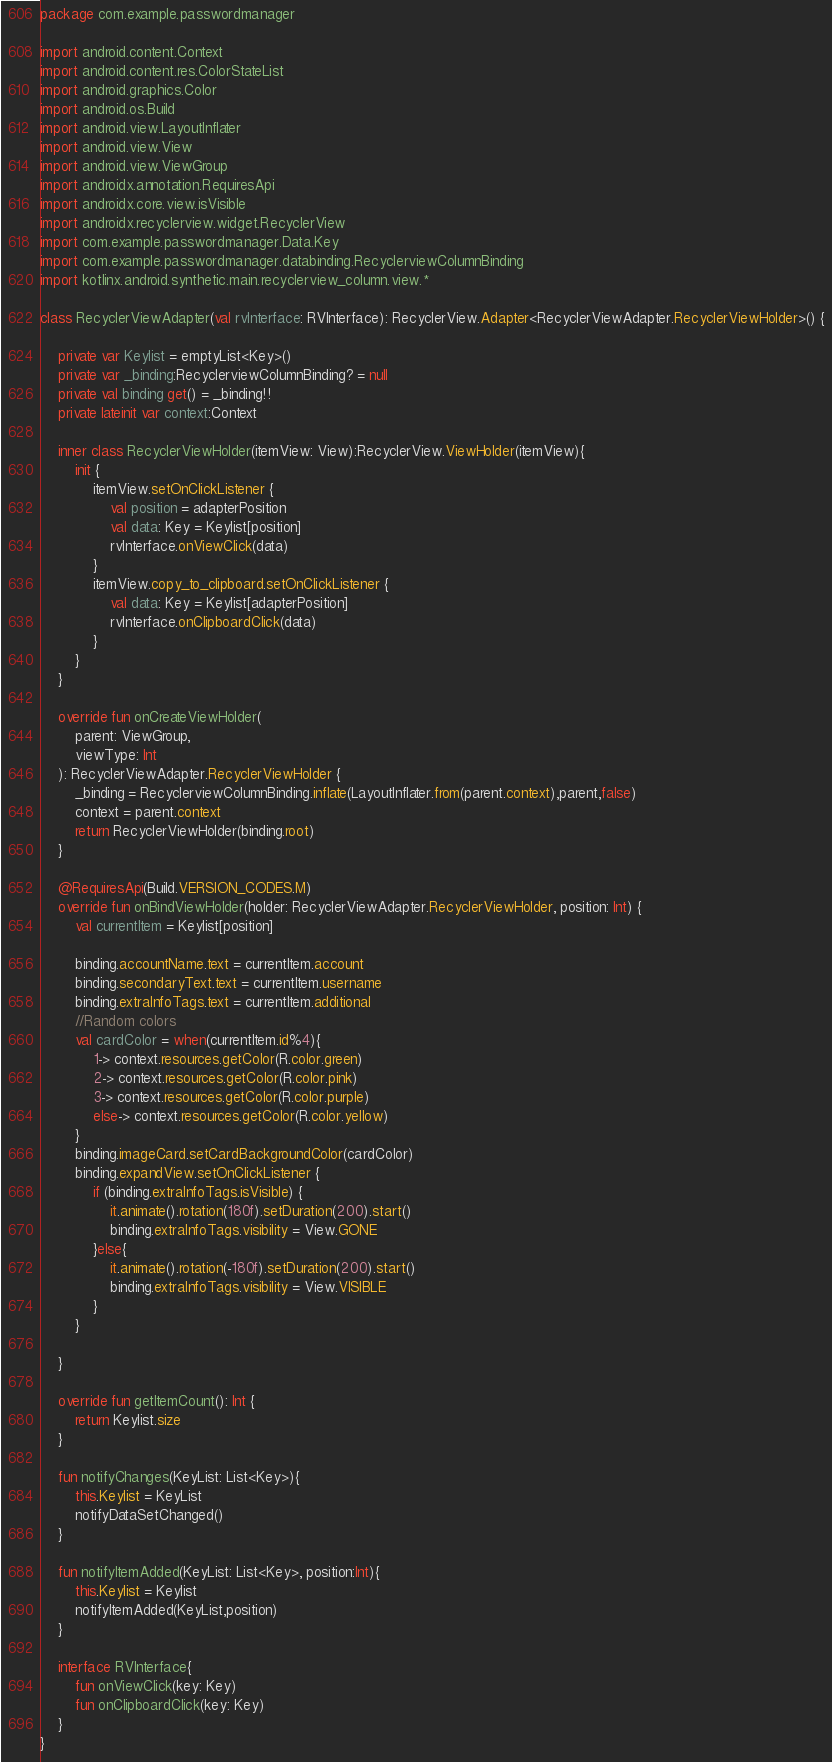Convert code to text. <code><loc_0><loc_0><loc_500><loc_500><_Kotlin_>package com.example.passwordmanager

import android.content.Context
import android.content.res.ColorStateList
import android.graphics.Color
import android.os.Build
import android.view.LayoutInflater
import android.view.View
import android.view.ViewGroup
import androidx.annotation.RequiresApi
import androidx.core.view.isVisible
import androidx.recyclerview.widget.RecyclerView
import com.example.passwordmanager.Data.Key
import com.example.passwordmanager.databinding.RecyclerviewColumnBinding
import kotlinx.android.synthetic.main.recyclerview_column.view.*

class RecyclerViewAdapter(val rvInterface: RVInterface): RecyclerView.Adapter<RecyclerViewAdapter.RecyclerViewHolder>() {

    private var Keylist = emptyList<Key>()
    private var _binding:RecyclerviewColumnBinding? = null
    private val binding get() = _binding!!
    private lateinit var context:Context

    inner class RecyclerViewHolder(itemView: View):RecyclerView.ViewHolder(itemView){
        init {
            itemView.setOnClickListener {
                val position = adapterPosition
                val data: Key = Keylist[position]
                rvInterface.onViewClick(data)
            }
            itemView.copy_to_clipboard.setOnClickListener {
                val data: Key = Keylist[adapterPosition]
                rvInterface.onClipboardClick(data)
            }
        }
    }

    override fun onCreateViewHolder(
        parent: ViewGroup,
        viewType: Int
    ): RecyclerViewAdapter.RecyclerViewHolder {
        _binding = RecyclerviewColumnBinding.inflate(LayoutInflater.from(parent.context),parent,false)
        context = parent.context
        return RecyclerViewHolder(binding.root)
    }

    @RequiresApi(Build.VERSION_CODES.M)
    override fun onBindViewHolder(holder: RecyclerViewAdapter.RecyclerViewHolder, position: Int) {
        val currentItem = Keylist[position]

        binding.accountName.text = currentItem.account
        binding.secondaryText.text = currentItem.username
        binding.extraInfoTags.text = currentItem.additional
        //Random colors
        val cardColor = when(currentItem.id%4){
            1-> context.resources.getColor(R.color.green)
            2-> context.resources.getColor(R.color.pink)
            3-> context.resources.getColor(R.color.purple)
            else-> context.resources.getColor(R.color.yellow)
        }
        binding.imageCard.setCardBackgroundColor(cardColor)
        binding.expandView.setOnClickListener {
            if (binding.extraInfoTags.isVisible) {
                it.animate().rotation(180f).setDuration(200).start()
                binding.extraInfoTags.visibility = View.GONE
            }else{
                it.animate().rotation(-180f).setDuration(200).start()
                binding.extraInfoTags.visibility = View.VISIBLE
            }
        }

    }

    override fun getItemCount(): Int {
        return Keylist.size
    }

    fun notifyChanges(KeyList: List<Key>){
        this.Keylist = KeyList
        notifyDataSetChanged()
    }

    fun notifyItemAdded(KeyList: List<Key>, position:Int){
        this.Keylist = Keylist
        notifyItemAdded(KeyList,position)
    }

    interface RVInterface{
        fun onViewClick(key: Key)
        fun onClipboardClick(key: Key)
    }
}</code> 